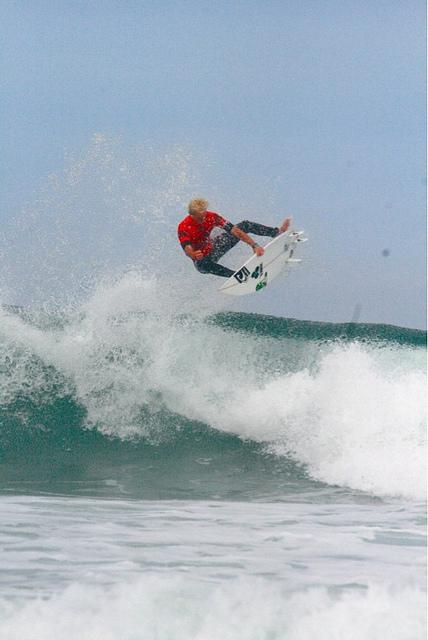Is this man surfing on a lake or an ocean?
Keep it brief. Ocean. Did this scene take place in a landlocked country?
Short answer required. No. Is this man surfing through a curl?
Concise answer only. Yes. 